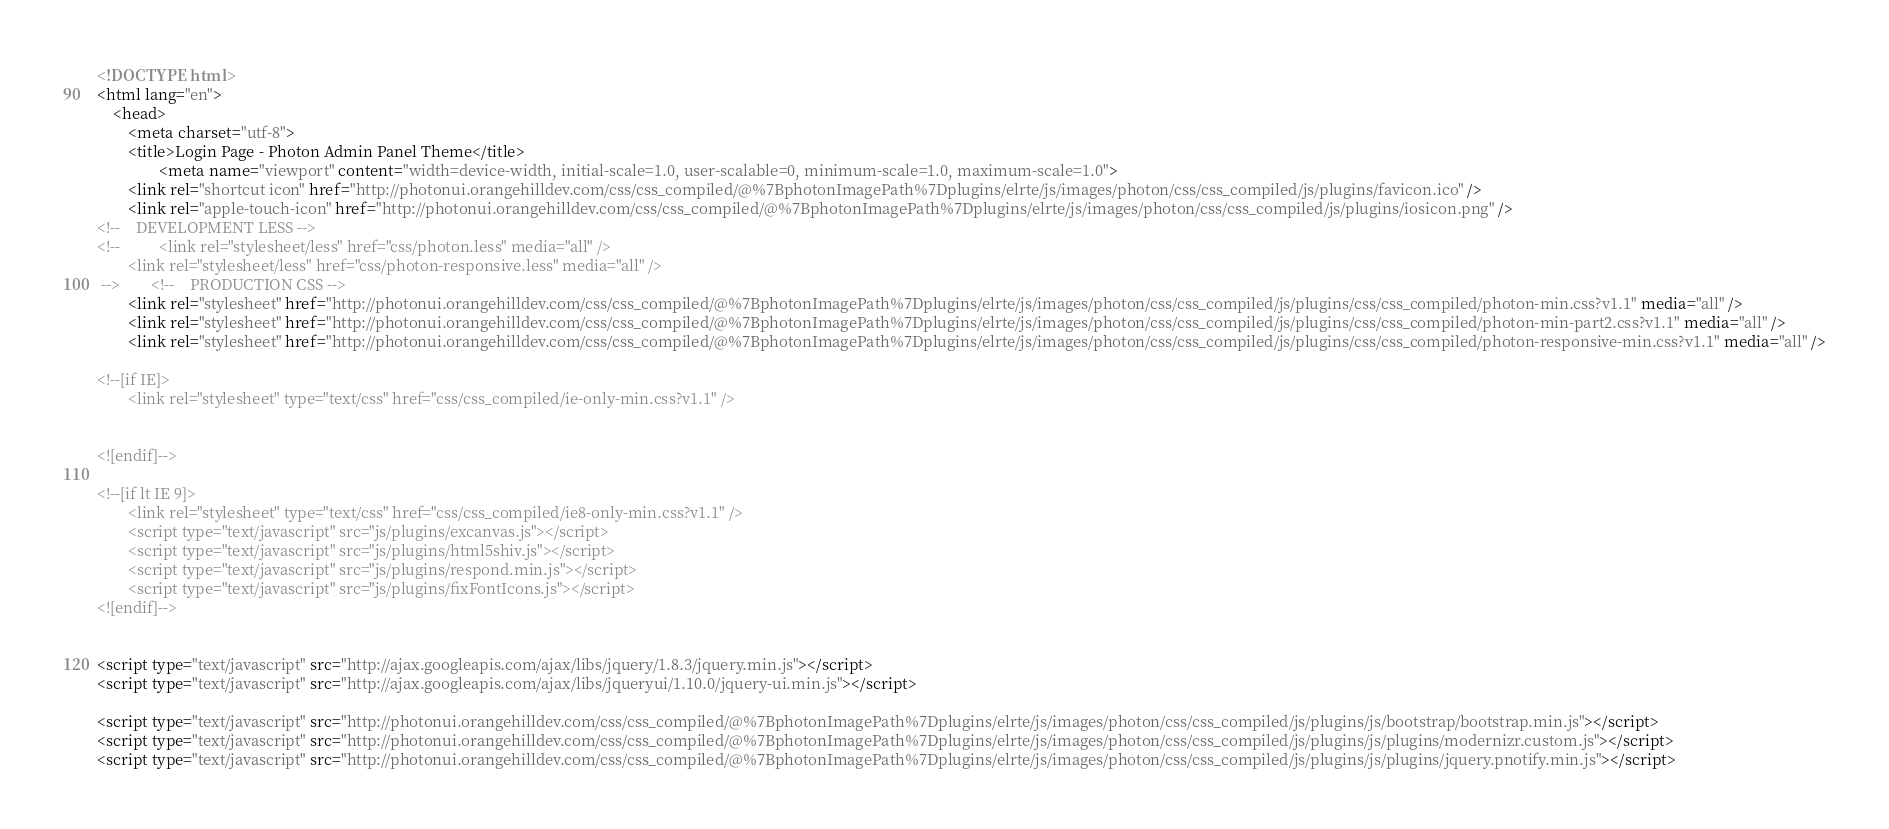<code> <loc_0><loc_0><loc_500><loc_500><_HTML_><!DOCTYPE html>
<html lang="en">
    <head>
        <meta charset="utf-8">
        <title>Login Page - Photon Admin Panel Theme</title>
                <meta name="viewport" content="width=device-width, initial-scale=1.0, user-scalable=0, minimum-scale=1.0, maximum-scale=1.0">
        <link rel="shortcut icon" href="http://photonui.orangehilldev.com/css/css_compiled/@%7BphotonImagePath%7Dplugins/elrte/js/images/photon/css/css_compiled/js/plugins/favicon.ico" />
        <link rel="apple-touch-icon" href="http://photonui.orangehilldev.com/css/css_compiled/@%7BphotonImagePath%7Dplugins/elrte/js/images/photon/css/css_compiled/js/plugins/iosicon.png" />
<!--    DEVELOPMENT LESS -->
<!--          <link rel="stylesheet/less" href="css/photon.less" media="all" />
        <link rel="stylesheet/less" href="css/photon-responsive.less" media="all" />
 -->        <!--    PRODUCTION CSS -->
        <link rel="stylesheet" href="http://photonui.orangehilldev.com/css/css_compiled/@%7BphotonImagePath%7Dplugins/elrte/js/images/photon/css/css_compiled/js/plugins/css/css_compiled/photon-min.css?v1.1" media="all" />
        <link rel="stylesheet" href="http://photonui.orangehilldev.com/css/css_compiled/@%7BphotonImagePath%7Dplugins/elrte/js/images/photon/css/css_compiled/js/plugins/css/css_compiled/photon-min-part2.css?v1.1" media="all" />
        <link rel="stylesheet" href="http://photonui.orangehilldev.com/css/css_compiled/@%7BphotonImagePath%7Dplugins/elrte/js/images/photon/css/css_compiled/js/plugins/css/css_compiled/photon-responsive-min.css?v1.1" media="all" />

<!--[if IE]>
        <link rel="stylesheet" type="text/css" href="css/css_compiled/ie-only-min.css?v1.1" />
        

<![endif]-->

<!--[if lt IE 9]>
        <link rel="stylesheet" type="text/css" href="css/css_compiled/ie8-only-min.css?v1.1" />
        <script type="text/javascript" src="js/plugins/excanvas.js"></script>
        <script type="text/javascript" src="js/plugins/html5shiv.js"></script>
        <script type="text/javascript" src="js/plugins/respond.min.js"></script>
        <script type="text/javascript" src="js/plugins/fixFontIcons.js"></script>
<![endif]-->

        
<script type="text/javascript" src="http://ajax.googleapis.com/ajax/libs/jquery/1.8.3/jquery.min.js"></script>
<script type="text/javascript" src="http://ajax.googleapis.com/ajax/libs/jqueryui/1.10.0/jquery-ui.min.js"></script>

<script type="text/javascript" src="http://photonui.orangehilldev.com/css/css_compiled/@%7BphotonImagePath%7Dplugins/elrte/js/images/photon/css/css_compiled/js/plugins/js/bootstrap/bootstrap.min.js"></script>
<script type="text/javascript" src="http://photonui.orangehilldev.com/css/css_compiled/@%7BphotonImagePath%7Dplugins/elrte/js/images/photon/css/css_compiled/js/plugins/js/plugins/modernizr.custom.js"></script>
<script type="text/javascript" src="http://photonui.orangehilldev.com/css/css_compiled/@%7BphotonImagePath%7Dplugins/elrte/js/images/photon/css/css_compiled/js/plugins/js/plugins/jquery.pnotify.min.js"></script></code> 